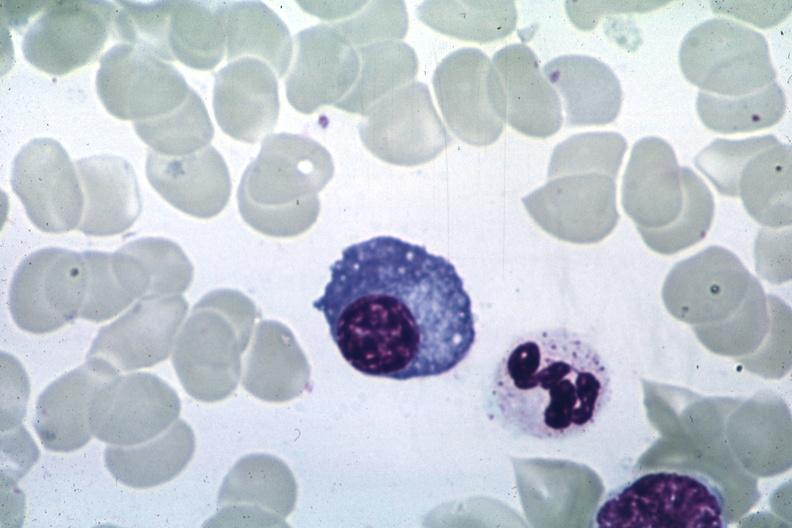what is present?
Answer the question using a single word or phrase. Hematologic 